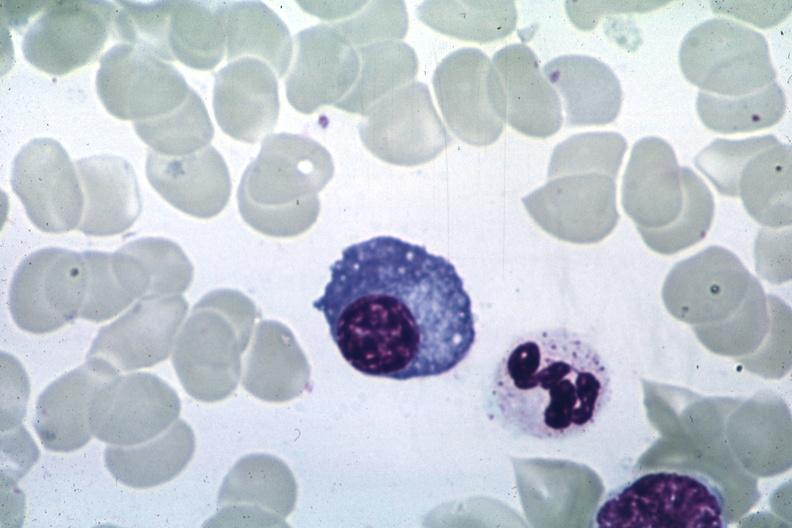what is present?
Answer the question using a single word or phrase. Hematologic 